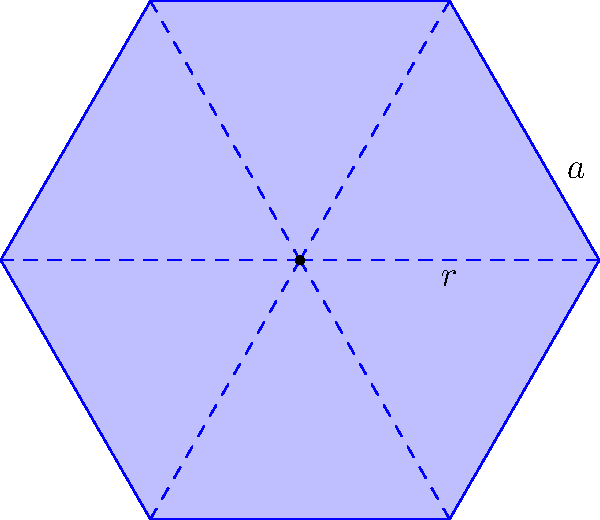In your latest novel, you describe a biologist studying honeycomb structures. The scientist notices that honey bees construct hexagonal cells to maximize storage efficiency. If the radius of the inscribed circle of a hexagonal cell is $r$, what is the area of the hexagon in terms of $r$, and why is this shape more efficient for space-filling compared to other polygons? Let's approach this step-by-step:

1) In a regular hexagon, the radius of the inscribed circle ($r$) is the apothem of the hexagon.

2) The side length ($a$) of the hexagon is related to $r$ by the equation:
   $a = r \tan(\frac{\pi}{6}) = r\frac{\sqrt{3}}{3}$

3) The area of a regular hexagon is given by:
   $A = \frac{3\sqrt{3}}{2}a^2$

4) Substituting the expression for $a$ in terms of $r$:
   $A = \frac{3\sqrt{3}}{2}(r\frac{\sqrt{3}}{3})^2$

5) Simplifying:
   $A = \frac{3\sqrt{3}}{2} \cdot \frac{3r^2}{9} = \frac{\sqrt{3}r^2}{2}$

6) Therefore, the area of the hexagon is $\frac{\sqrt{3}r^2}{2}$.

7) Hexagons are more efficient for space-filling because:
   a) They tessellate perfectly, leaving no gaps.
   b) Among all regular polygons that tessellate, hexagons have the largest area-to-perimeter ratio.
   c) This means hexagons require less wax to construct while maximizing storage volume.

8) Mathematically, the ratio of area to perimeter squared (a measure of efficiency) for regular polygons approaches $\frac{1}{4\pi}$ as the number of sides increases. Hexagons are the polygon with the fewest sides that comes closest to this limit while still being able to tessellate.
Answer: $\frac{\sqrt{3}r^2}{2}$; hexagons maximize area-to-perimeter ratio among tessellating polygons. 